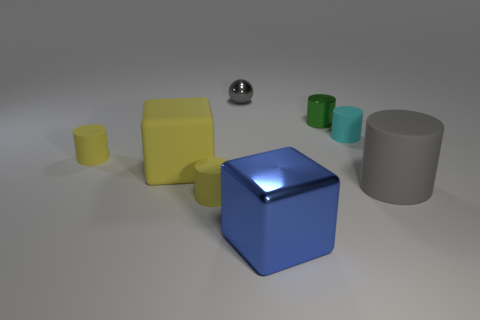What number of tiny cyan matte objects are the same shape as the big gray thing?
Offer a terse response. 1. What is the shape of the blue metal object?
Ensure brevity in your answer.  Cube. Are there an equal number of green things that are left of the big metallic thing and big cyan rubber spheres?
Offer a terse response. Yes. Is the material of the large cube that is on the left side of the tiny gray thing the same as the big gray cylinder?
Your response must be concise. Yes. Are there fewer big blue shiny things to the left of the metallic sphere than large yellow rubber things?
Provide a short and direct response. Yes. How many matte things are tiny green objects or small gray things?
Give a very brief answer. 0. Do the tiny metal sphere and the large matte cylinder have the same color?
Ensure brevity in your answer.  Yes. Is there anything else that has the same color as the large matte cylinder?
Your answer should be compact. Yes. Do the gray object that is right of the cyan rubber object and the metallic object that is right of the blue metal block have the same shape?
Your answer should be compact. Yes. What number of things are large metallic things or matte things that are left of the green shiny thing?
Provide a short and direct response. 4. 